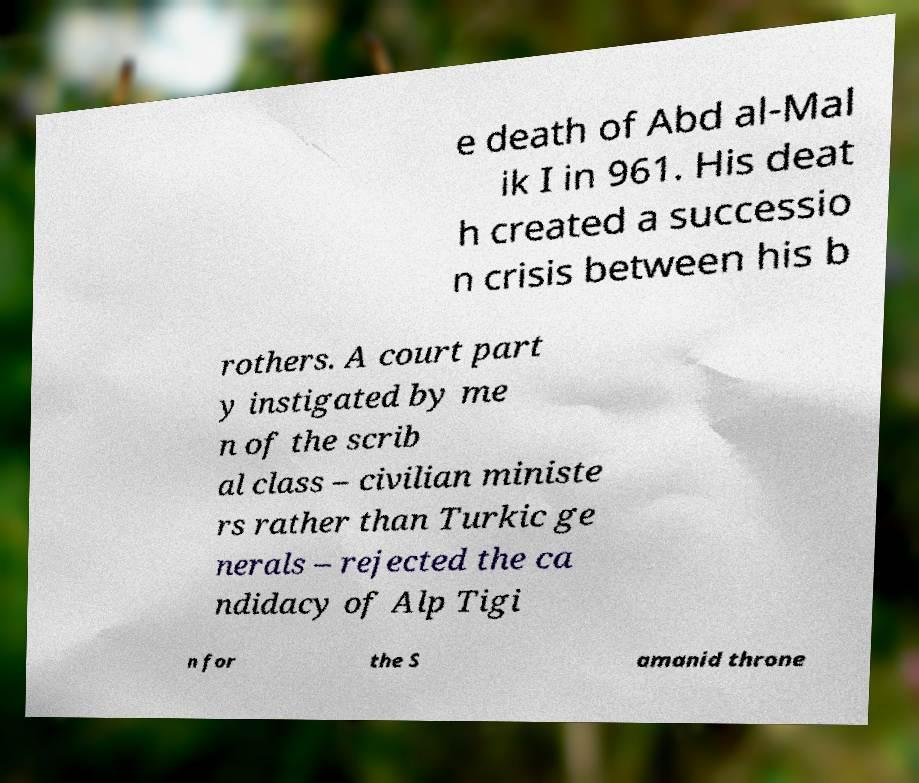Can you read and provide the text displayed in the image?This photo seems to have some interesting text. Can you extract and type it out for me? e death of Abd al-Mal ik I in 961. His deat h created a successio n crisis between his b rothers. A court part y instigated by me n of the scrib al class – civilian ministe rs rather than Turkic ge nerals – rejected the ca ndidacy of Alp Tigi n for the S amanid throne 